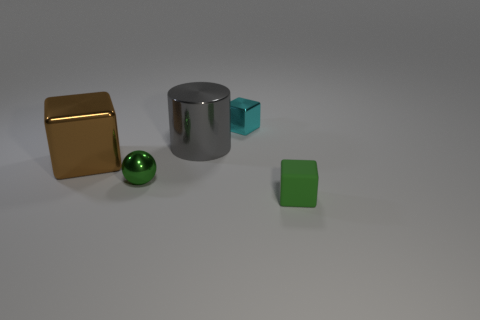There is a object that is to the right of the tiny cyan object; what is its size?
Offer a very short reply. Small. The cyan block that is made of the same material as the large cylinder is what size?
Offer a very short reply. Small. How many rubber things have the same color as the matte block?
Make the answer very short. 0. Is there a green sphere?
Give a very brief answer. Yes. Is the shape of the small green matte thing the same as the big thing on the right side of the small green metal thing?
Your response must be concise. No. There is a small thing on the right side of the tiny block left of the tiny green thing right of the cyan shiny block; what is its color?
Make the answer very short. Green. There is a large gray thing; are there any large gray cylinders behind it?
Your response must be concise. No. There is a rubber thing that is the same color as the metal ball; what size is it?
Your answer should be compact. Small. Are there any tiny brown cylinders that have the same material as the green cube?
Ensure brevity in your answer.  No. What color is the big block?
Make the answer very short. Brown. 